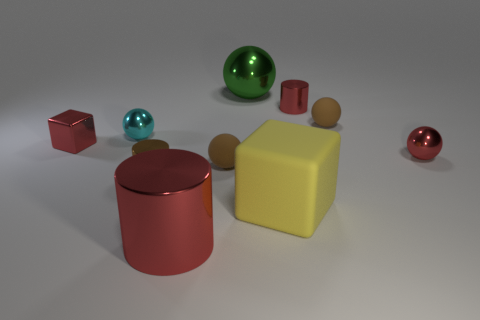Subtract all small red spheres. How many spheres are left? 4 Subtract all brown spheres. How many spheres are left? 3 Subtract 4 spheres. How many spheres are left? 1 Subtract all cylinders. How many objects are left? 7 Subtract all big purple matte objects. Subtract all metal balls. How many objects are left? 7 Add 8 big cubes. How many big cubes are left? 9 Add 4 small gray cubes. How many small gray cubes exist? 4 Subtract 0 cyan cubes. How many objects are left? 10 Subtract all green spheres. Subtract all gray cubes. How many spheres are left? 4 Subtract all red balls. How many yellow blocks are left? 1 